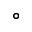<formula> <loc_0><loc_0><loc_500><loc_500>^ { \circ }</formula> 